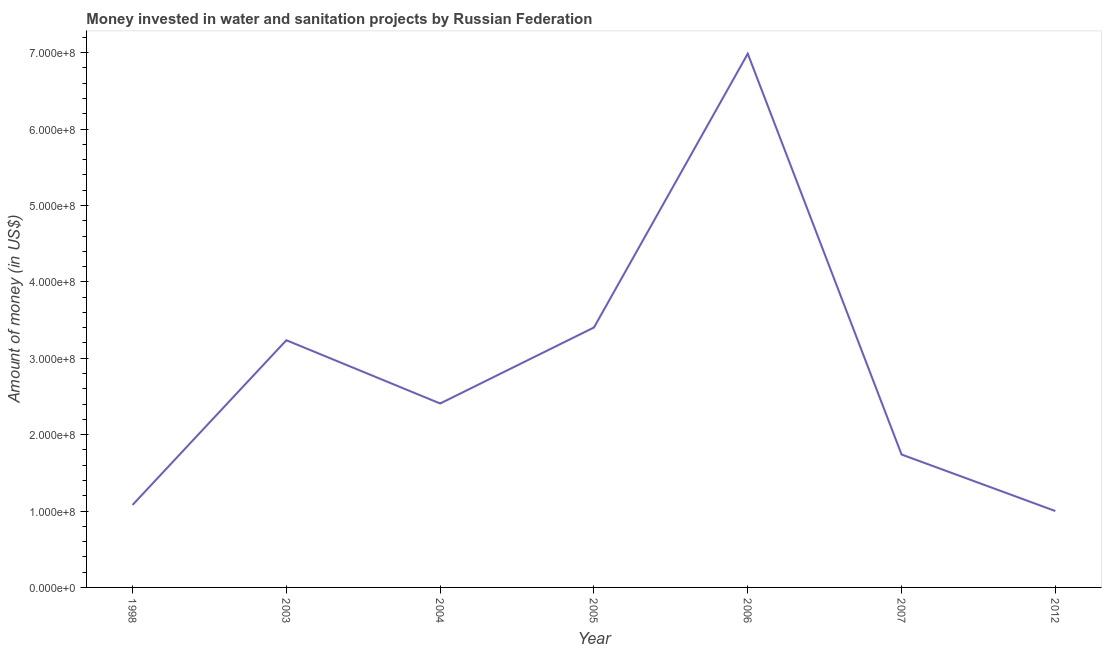What is the investment in 2006?
Your response must be concise. 6.99e+08. Across all years, what is the maximum investment?
Offer a very short reply. 6.99e+08. Across all years, what is the minimum investment?
Your answer should be very brief. 1.00e+08. In which year was the investment minimum?
Make the answer very short. 2012. What is the sum of the investment?
Give a very brief answer. 1.99e+09. What is the difference between the investment in 2005 and 2007?
Offer a terse response. 1.66e+08. What is the average investment per year?
Keep it short and to the point. 2.84e+08. What is the median investment?
Ensure brevity in your answer.  2.41e+08. In how many years, is the investment greater than 440000000 US$?
Offer a very short reply. 1. What is the ratio of the investment in 2004 to that in 2005?
Offer a terse response. 0.71. Is the difference between the investment in 1998 and 2005 greater than the difference between any two years?
Give a very brief answer. No. What is the difference between the highest and the second highest investment?
Give a very brief answer. 3.58e+08. What is the difference between the highest and the lowest investment?
Provide a short and direct response. 5.99e+08. In how many years, is the investment greater than the average investment taken over all years?
Ensure brevity in your answer.  3. How many years are there in the graph?
Your answer should be compact. 7. Are the values on the major ticks of Y-axis written in scientific E-notation?
Make the answer very short. Yes. Does the graph contain grids?
Provide a short and direct response. No. What is the title of the graph?
Provide a short and direct response. Money invested in water and sanitation projects by Russian Federation. What is the label or title of the X-axis?
Offer a very short reply. Year. What is the label or title of the Y-axis?
Offer a very short reply. Amount of money (in US$). What is the Amount of money (in US$) of 1998?
Your answer should be very brief. 1.08e+08. What is the Amount of money (in US$) in 2003?
Keep it short and to the point. 3.24e+08. What is the Amount of money (in US$) of 2004?
Offer a very short reply. 2.41e+08. What is the Amount of money (in US$) in 2005?
Keep it short and to the point. 3.40e+08. What is the Amount of money (in US$) of 2006?
Offer a terse response. 6.99e+08. What is the Amount of money (in US$) of 2007?
Ensure brevity in your answer.  1.74e+08. What is the difference between the Amount of money (in US$) in 1998 and 2003?
Ensure brevity in your answer.  -2.16e+08. What is the difference between the Amount of money (in US$) in 1998 and 2004?
Make the answer very short. -1.33e+08. What is the difference between the Amount of money (in US$) in 1998 and 2005?
Your answer should be very brief. -2.32e+08. What is the difference between the Amount of money (in US$) in 1998 and 2006?
Offer a terse response. -5.91e+08. What is the difference between the Amount of money (in US$) in 1998 and 2007?
Your response must be concise. -6.60e+07. What is the difference between the Amount of money (in US$) in 2003 and 2004?
Provide a short and direct response. 8.28e+07. What is the difference between the Amount of money (in US$) in 2003 and 2005?
Give a very brief answer. -1.67e+07. What is the difference between the Amount of money (in US$) in 2003 and 2006?
Offer a terse response. -3.75e+08. What is the difference between the Amount of money (in US$) in 2003 and 2007?
Keep it short and to the point. 1.50e+08. What is the difference between the Amount of money (in US$) in 2003 and 2012?
Give a very brief answer. 2.24e+08. What is the difference between the Amount of money (in US$) in 2004 and 2005?
Offer a terse response. -9.95e+07. What is the difference between the Amount of money (in US$) in 2004 and 2006?
Keep it short and to the point. -4.58e+08. What is the difference between the Amount of money (in US$) in 2004 and 2007?
Make the answer very short. 6.68e+07. What is the difference between the Amount of money (in US$) in 2004 and 2012?
Ensure brevity in your answer.  1.41e+08. What is the difference between the Amount of money (in US$) in 2005 and 2006?
Make the answer very short. -3.58e+08. What is the difference between the Amount of money (in US$) in 2005 and 2007?
Offer a very short reply. 1.66e+08. What is the difference between the Amount of money (in US$) in 2005 and 2012?
Provide a succinct answer. 2.40e+08. What is the difference between the Amount of money (in US$) in 2006 and 2007?
Provide a succinct answer. 5.25e+08. What is the difference between the Amount of money (in US$) in 2006 and 2012?
Make the answer very short. 5.99e+08. What is the difference between the Amount of money (in US$) in 2007 and 2012?
Offer a terse response. 7.40e+07. What is the ratio of the Amount of money (in US$) in 1998 to that in 2003?
Provide a succinct answer. 0.33. What is the ratio of the Amount of money (in US$) in 1998 to that in 2004?
Provide a succinct answer. 0.45. What is the ratio of the Amount of money (in US$) in 1998 to that in 2005?
Offer a terse response. 0.32. What is the ratio of the Amount of money (in US$) in 1998 to that in 2006?
Make the answer very short. 0.15. What is the ratio of the Amount of money (in US$) in 1998 to that in 2007?
Make the answer very short. 0.62. What is the ratio of the Amount of money (in US$) in 1998 to that in 2012?
Your response must be concise. 1.08. What is the ratio of the Amount of money (in US$) in 2003 to that in 2004?
Your answer should be compact. 1.34. What is the ratio of the Amount of money (in US$) in 2003 to that in 2005?
Make the answer very short. 0.95. What is the ratio of the Amount of money (in US$) in 2003 to that in 2006?
Ensure brevity in your answer.  0.46. What is the ratio of the Amount of money (in US$) in 2003 to that in 2007?
Make the answer very short. 1.86. What is the ratio of the Amount of money (in US$) in 2003 to that in 2012?
Offer a very short reply. 3.24. What is the ratio of the Amount of money (in US$) in 2004 to that in 2005?
Provide a short and direct response. 0.71. What is the ratio of the Amount of money (in US$) in 2004 to that in 2006?
Provide a short and direct response. 0.34. What is the ratio of the Amount of money (in US$) in 2004 to that in 2007?
Your answer should be compact. 1.38. What is the ratio of the Amount of money (in US$) in 2004 to that in 2012?
Ensure brevity in your answer.  2.41. What is the ratio of the Amount of money (in US$) in 2005 to that in 2006?
Your answer should be very brief. 0.49. What is the ratio of the Amount of money (in US$) in 2005 to that in 2007?
Give a very brief answer. 1.96. What is the ratio of the Amount of money (in US$) in 2005 to that in 2012?
Offer a very short reply. 3.4. What is the ratio of the Amount of money (in US$) in 2006 to that in 2007?
Provide a succinct answer. 4.02. What is the ratio of the Amount of money (in US$) in 2006 to that in 2012?
Make the answer very short. 6.99. What is the ratio of the Amount of money (in US$) in 2007 to that in 2012?
Provide a short and direct response. 1.74. 